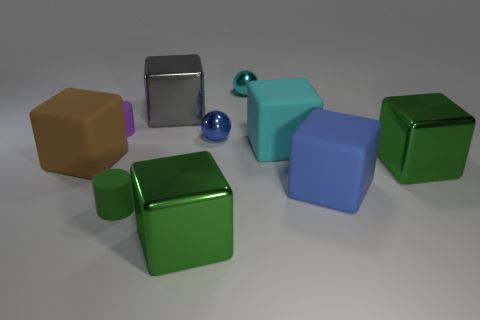Subtract all green cubes. How many were subtracted if there are1green cubes left? 1 Subtract all blue cubes. How many cubes are left? 5 Subtract all cyan blocks. How many blocks are left? 5 Subtract all cubes. How many objects are left? 4 Subtract 1 blocks. How many blocks are left? 5 Subtract all purple blocks. Subtract all green cylinders. How many blocks are left? 6 Subtract all red balls. How many purple cylinders are left? 1 Subtract all tiny blue blocks. Subtract all small purple objects. How many objects are left? 9 Add 1 blocks. How many blocks are left? 7 Add 1 big gray rubber cubes. How many big gray rubber cubes exist? 1 